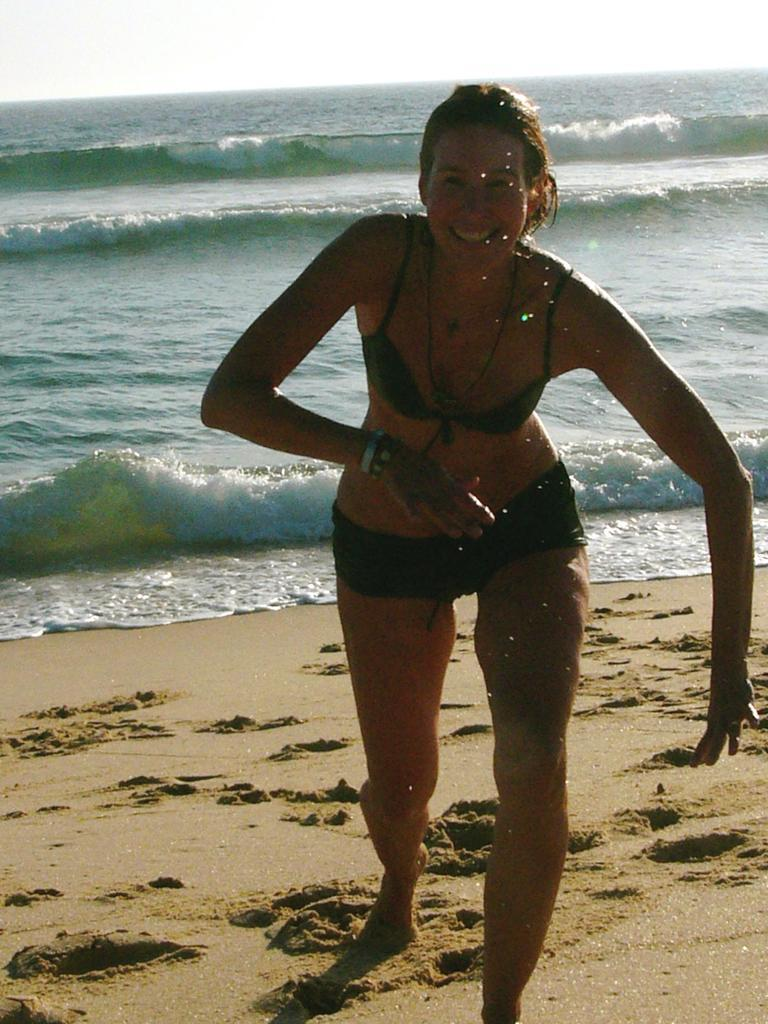Who is present in the image? There is a lady in the image. Where is the lady located? The lady is standing at the seashore. What is the setting of the image? The location is on the beach. What shape is the lady's stomach in the image? A: There is no information about the shape of the lady's stomach in the image. 